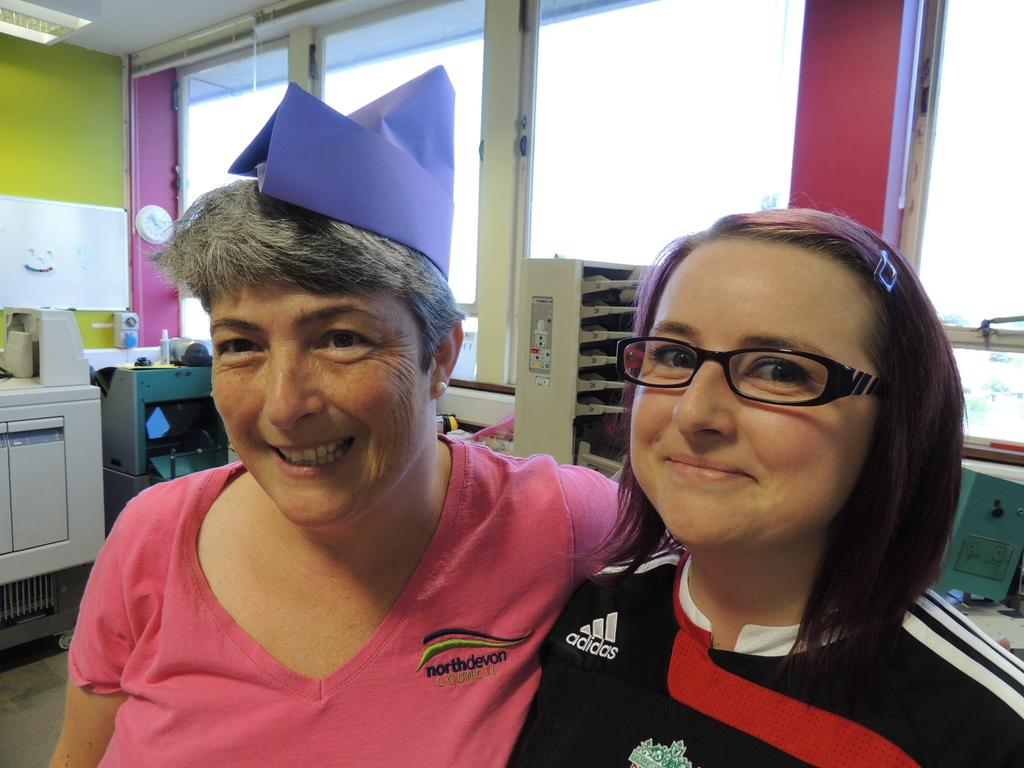What is the lady in the image wearing? There is a lady wearing a pink dress in the image. What is on the lady's head? There is a violet color object on the lady's head. Is there anyone else in the image? Yes, there is another lady standing beside the first lady. What can be seen in the background of the image? There are other objects visible in the background of the image. What type of coal is being used for the lady's pet's education in the image? There is no coal, pet, or education present in the image. 